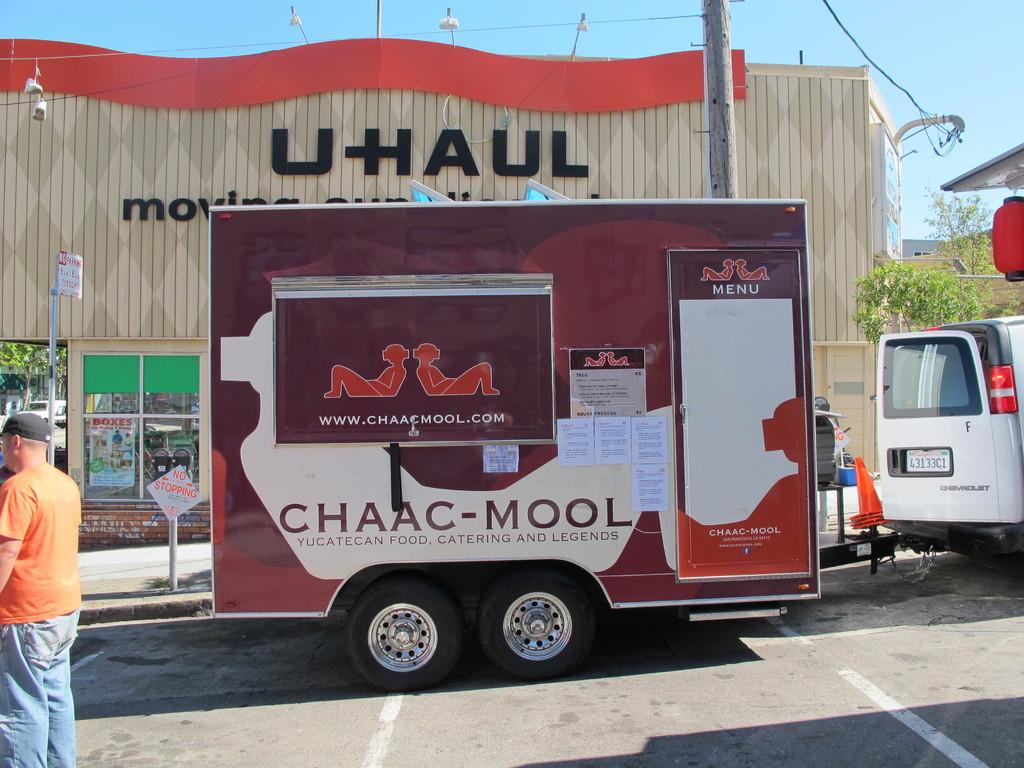What can be seen in the sky in the image? The sky is visible in the image. What type of structure is present in the image? There is a building in the image. What type of lighting is present in the image? Electric lights are present in the image. What type of vertical structures are visible in the image? Poles are visible in the image. What type of natural vegetation is present in the image? Trees are present in the image. What type of transportation is present on the road in the image? Motor vehicles are on the road in the image. What type of signage is present in the image? Sign boards are in the image. What type of traffic control is present in the image? Traffic cones are in the image. What type of person is present in the image? There is a person standing on the road in the image. How many umbrellas are open in the image? There are no umbrellas present in the image. What type of debt is visible in the image? There is no debt visible in the image. What type of nocturnal creature is present in the image? There is no owl or any other nocturnal creature present in the image. 